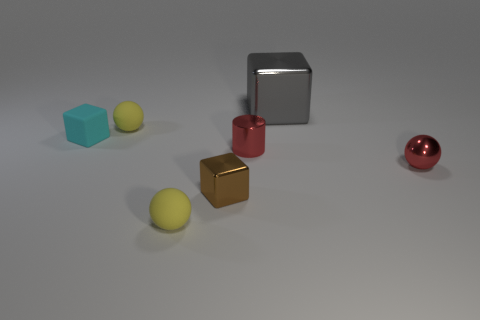What number of other objects are there of the same color as the big metal cube? 0 